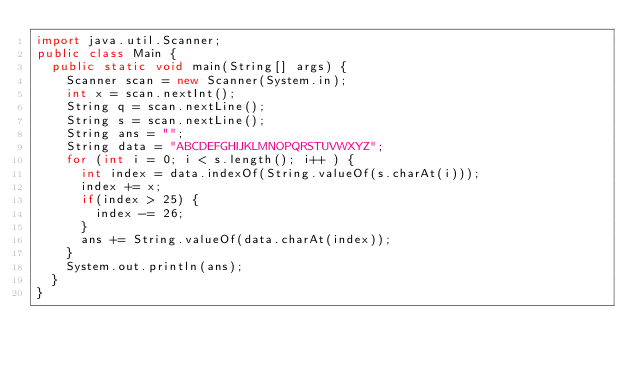<code> <loc_0><loc_0><loc_500><loc_500><_Java_>import java.util.Scanner;
public class Main {
	public static void main(String[] args) {
		Scanner scan = new Scanner(System.in);
		int x = scan.nextInt();
		String q = scan.nextLine();
		String s = scan.nextLine();
		String ans = "";
		String data = "ABCDEFGHIJKLMNOPQRSTUVWXYZ";
		for (int i = 0; i < s.length(); i++ ) {
			int index = data.indexOf(String.valueOf(s.charAt(i)));
			index += x;
			if(index > 25) {
				index -= 26;
			}
			ans += String.valueOf(data.charAt(index));
		}
		System.out.println(ans);
	}
}
</code> 